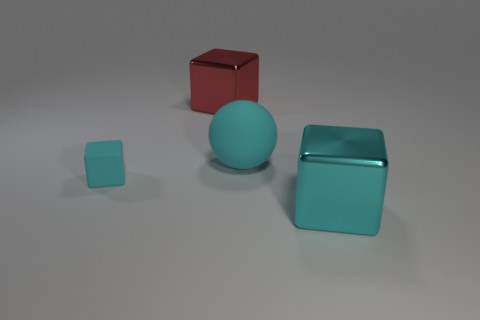How many other things are the same size as the cyan matte cube? Among the objects in the image, none share the exact same size as the cyan matte cube. The red cube and the smaller aqua cube are of different dimensions, and the sphere does not match in shape or size. 